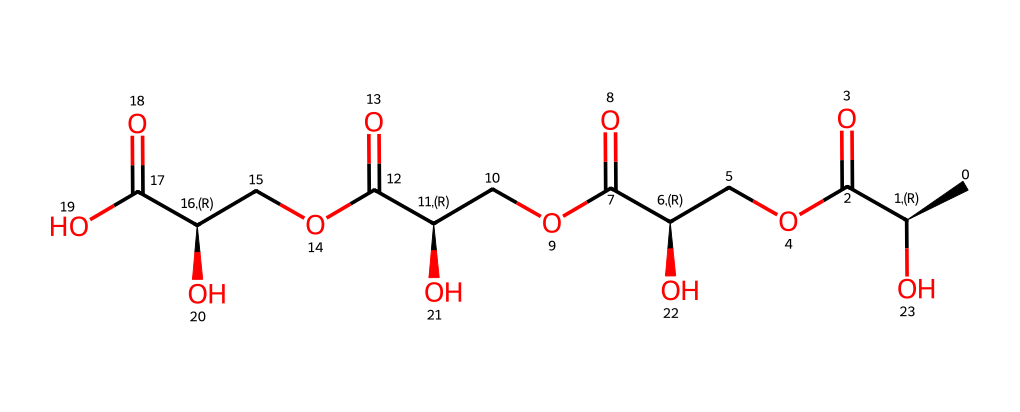What is the name of this chemical? The structure conforms to the known characteristics of poly(lactic-co-glycolic acid) (PLGA), which consists of lactic acid and glycolic acid units.
Answer: poly(lactic-co-glycolic acid) How many carbon atoms are in this molecule? Analyzing the SMILES, there are 8 carbon (C) atoms indicated by their respective positions in the chain of the structure.
Answer: 8 What type of functional groups are present in PLGA? The presence of ester groups is indicated by the connectivity of carbon to oxygen, specifically in the structure where there are carbonyls adjacent to oxygens.
Answer: esters What is the significance of the repeating units in PLGA? PLGA is composed of lactic acid and glycolic acid repeating units, which influence its mechanical properties and degradation rate, making it suitable for tissue engineering applications.
Answer: mechanical properties What molecular structure characterizes PLGA as a non-electrolyte? PLGA, being a polymer with no ionizable groups in its structure, does not conduct electricity, hence categorizing it as a non-electrolyte.
Answer: no ionizable groups Which functional group indicates the biodegradability of PLGA? The presence of ester groups in the structure is critical as they can hydrolyze in biological environments, leading to the material's biodegradability.
Answer: esters 